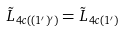Convert formula to latex. <formula><loc_0><loc_0><loc_500><loc_500>\tilde { L } _ { 4 c ( ( 1 ^ { \prime } ) ^ { \prime } ) } & = \tilde { L } _ { 4 c ( 1 ^ { \prime } ) }</formula> 